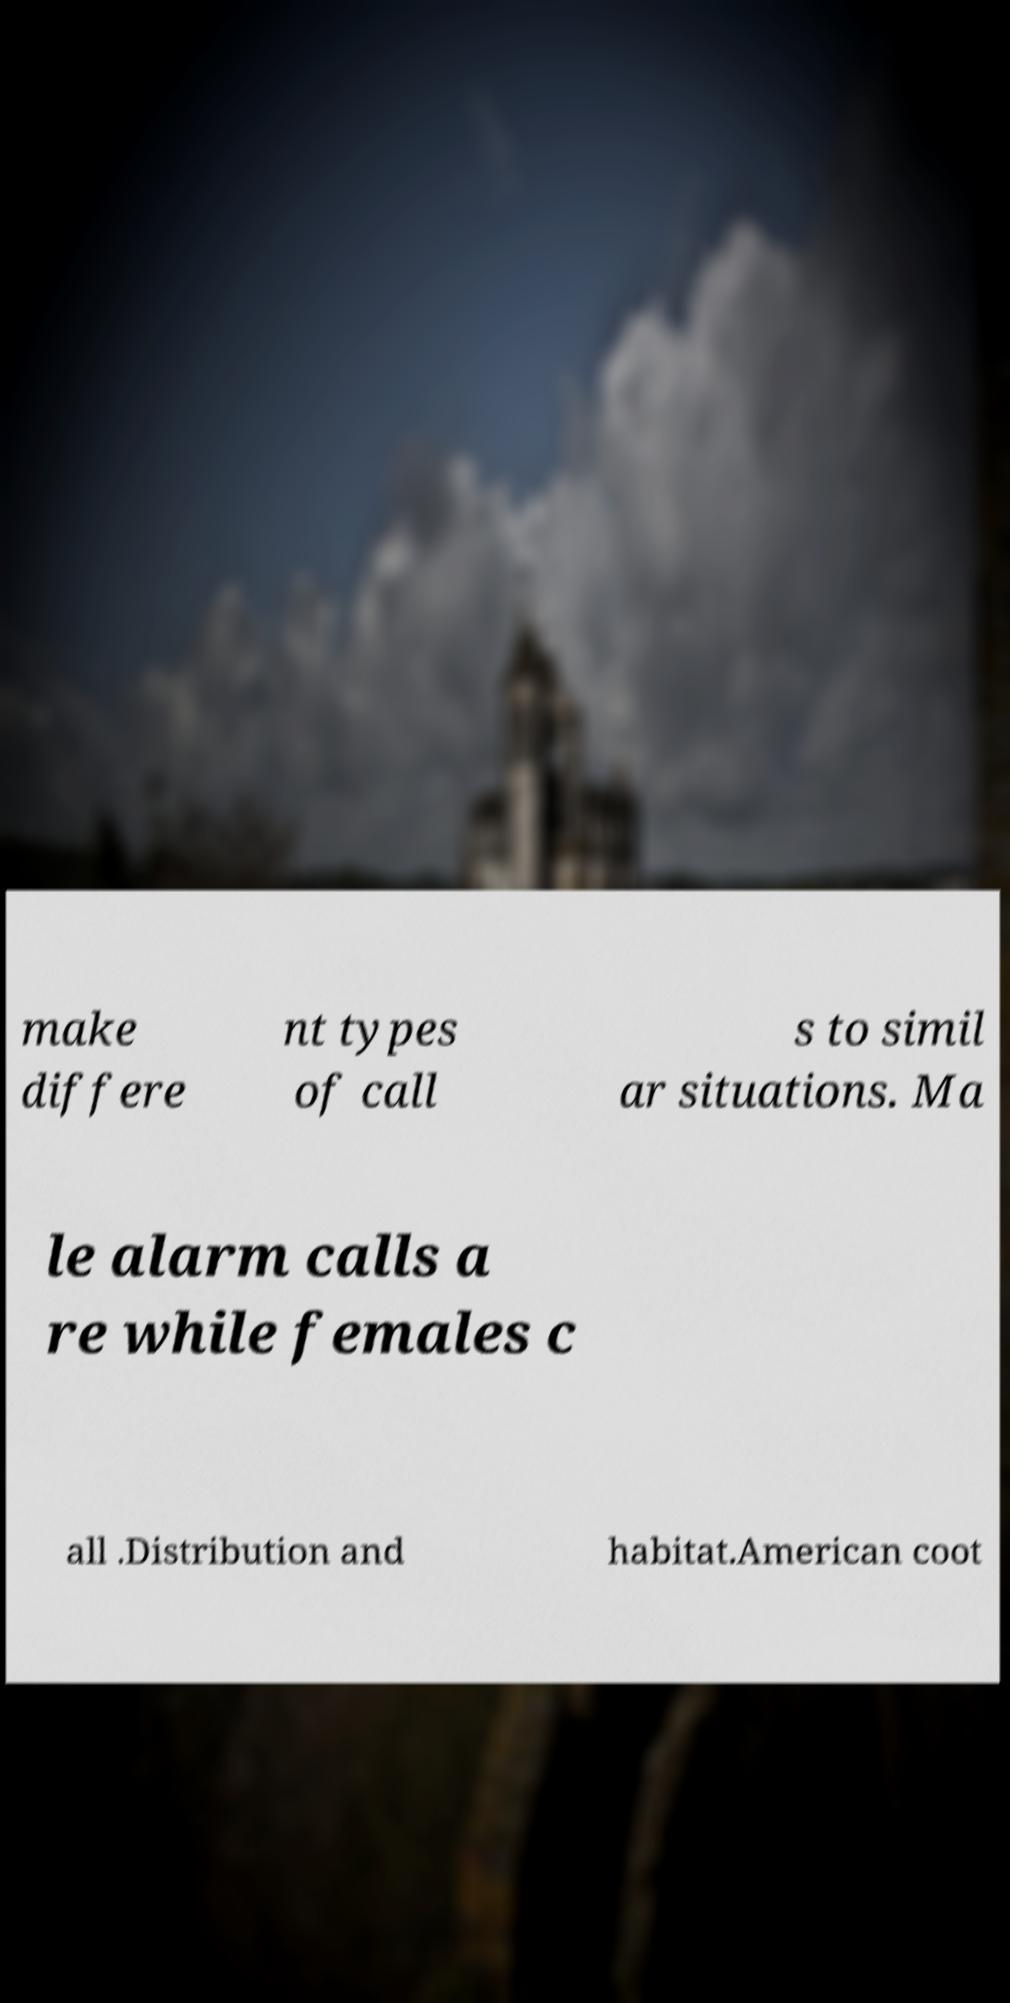I need the written content from this picture converted into text. Can you do that? make differe nt types of call s to simil ar situations. Ma le alarm calls a re while females c all .Distribution and habitat.American coot 